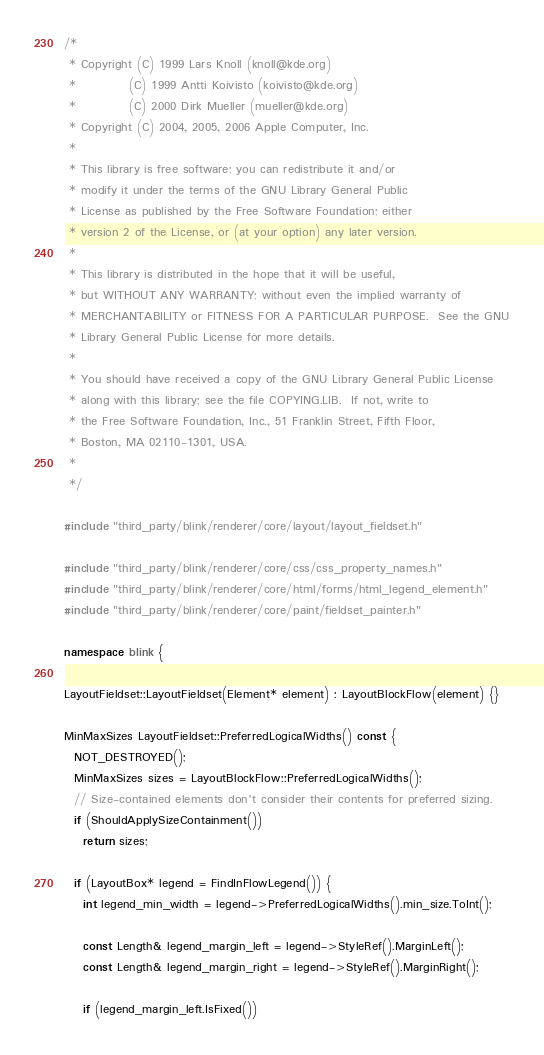<code> <loc_0><loc_0><loc_500><loc_500><_C++_>/*
 * Copyright (C) 1999 Lars Knoll (knoll@kde.org)
 *           (C) 1999 Antti Koivisto (koivisto@kde.org)
 *           (C) 2000 Dirk Mueller (mueller@kde.org)
 * Copyright (C) 2004, 2005, 2006 Apple Computer, Inc.
 *
 * This library is free software; you can redistribute it and/or
 * modify it under the terms of the GNU Library General Public
 * License as published by the Free Software Foundation; either
 * version 2 of the License, or (at your option) any later version.
 *
 * This library is distributed in the hope that it will be useful,
 * but WITHOUT ANY WARRANTY; without even the implied warranty of
 * MERCHANTABILITY or FITNESS FOR A PARTICULAR PURPOSE.  See the GNU
 * Library General Public License for more details.
 *
 * You should have received a copy of the GNU Library General Public License
 * along with this library; see the file COPYING.LIB.  If not, write to
 * the Free Software Foundation, Inc., 51 Franklin Street, Fifth Floor,
 * Boston, MA 02110-1301, USA.
 *
 */

#include "third_party/blink/renderer/core/layout/layout_fieldset.h"

#include "third_party/blink/renderer/core/css/css_property_names.h"
#include "third_party/blink/renderer/core/html/forms/html_legend_element.h"
#include "third_party/blink/renderer/core/paint/fieldset_painter.h"

namespace blink {

LayoutFieldset::LayoutFieldset(Element* element) : LayoutBlockFlow(element) {}

MinMaxSizes LayoutFieldset::PreferredLogicalWidths() const {
  NOT_DESTROYED();
  MinMaxSizes sizes = LayoutBlockFlow::PreferredLogicalWidths();
  // Size-contained elements don't consider their contents for preferred sizing.
  if (ShouldApplySizeContainment())
    return sizes;

  if (LayoutBox* legend = FindInFlowLegend()) {
    int legend_min_width = legend->PreferredLogicalWidths().min_size.ToInt();

    const Length& legend_margin_left = legend->StyleRef().MarginLeft();
    const Length& legend_margin_right = legend->StyleRef().MarginRight();

    if (legend_margin_left.IsFixed())</code> 